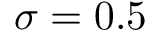Convert formula to latex. <formula><loc_0><loc_0><loc_500><loc_500>\sigma = 0 . 5</formula> 